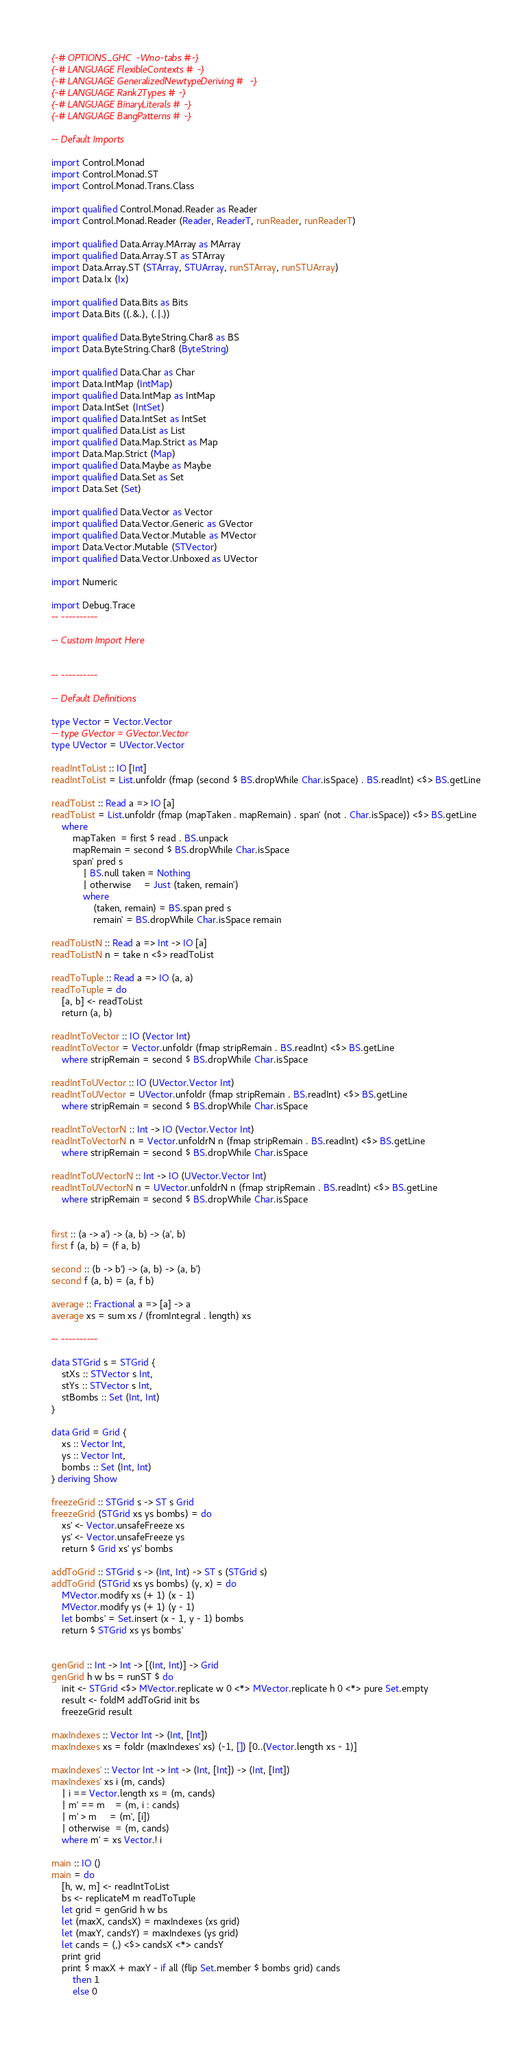<code> <loc_0><loc_0><loc_500><loc_500><_Haskell_>{-# OPTIONS_GHC -Wno-tabs #-}
{-# LANGUAGE FlexibleContexts #-}
{-# LANGUAGE GeneralizedNewtypeDeriving #-}
{-# LANGUAGE Rank2Types #-}
{-# LANGUAGE BinaryLiterals #-}
{-# LANGUAGE BangPatterns #-}

-- Default Imports

import Control.Monad
import Control.Monad.ST
import Control.Monad.Trans.Class

import qualified Control.Monad.Reader as Reader
import Control.Monad.Reader (Reader, ReaderT, runReader, runReaderT)

import qualified Data.Array.MArray as MArray
import qualified Data.Array.ST as STArray
import Data.Array.ST (STArray, STUArray, runSTArray, runSTUArray)
import Data.Ix (Ix)

import qualified Data.Bits as Bits
import Data.Bits ((.&.), (.|.))

import qualified Data.ByteString.Char8 as BS
import Data.ByteString.Char8 (ByteString)

import qualified Data.Char as Char
import Data.IntMap (IntMap)
import qualified Data.IntMap as IntMap
import Data.IntSet (IntSet)
import qualified Data.IntSet as IntSet
import qualified Data.List as List
import qualified Data.Map.Strict as Map
import Data.Map.Strict (Map)
import qualified Data.Maybe as Maybe
import qualified Data.Set as Set
import Data.Set (Set)

import qualified Data.Vector as Vector
import qualified Data.Vector.Generic as GVector
import qualified Data.Vector.Mutable as MVector
import Data.Vector.Mutable (STVector)
import qualified Data.Vector.Unboxed as UVector

import Numeric

import Debug.Trace
-- ----------

-- Custom Import Here


-- ----------

-- Default Definitions

type Vector = Vector.Vector
-- type GVector = GVector.Vector
type UVector = UVector.Vector

readIntToList :: IO [Int]
readIntToList = List.unfoldr (fmap (second $ BS.dropWhile Char.isSpace) . BS.readInt) <$> BS.getLine

readToList :: Read a => IO [a]
readToList = List.unfoldr (fmap (mapTaken . mapRemain) . span' (not . Char.isSpace)) <$> BS.getLine
	where
		mapTaken  = first $ read . BS.unpack
		mapRemain = second $ BS.dropWhile Char.isSpace
		span' pred s
			| BS.null taken = Nothing
			| otherwise     = Just (taken, remain')
			where
				(taken, remain) = BS.span pred s
				remain' = BS.dropWhile Char.isSpace remain

readToListN :: Read a => Int -> IO [a]
readToListN n = take n <$> readToList

readToTuple :: Read a => IO (a, a)
readToTuple = do
	[a, b] <- readToList
	return (a, b)

readIntToVector :: IO (Vector Int)
readIntToVector = Vector.unfoldr (fmap stripRemain . BS.readInt) <$> BS.getLine
	where stripRemain = second $ BS.dropWhile Char.isSpace

readIntToUVector :: IO (UVector.Vector Int)
readIntToUVector = UVector.unfoldr (fmap stripRemain . BS.readInt) <$> BS.getLine
	where stripRemain = second $ BS.dropWhile Char.isSpace

readIntToVectorN :: Int -> IO (Vector.Vector Int)
readIntToVectorN n = Vector.unfoldrN n (fmap stripRemain . BS.readInt) <$> BS.getLine
	where stripRemain = second $ BS.dropWhile Char.isSpace

readIntToUVectorN :: Int -> IO (UVector.Vector Int)
readIntToUVectorN n = UVector.unfoldrN n (fmap stripRemain . BS.readInt) <$> BS.getLine
	where stripRemain = second $ BS.dropWhile Char.isSpace


first :: (a -> a') -> (a, b) -> (a', b)
first f (a, b) = (f a, b)

second :: (b -> b') -> (a, b) -> (a, b')
second f (a, b) = (a, f b)

average :: Fractional a => [a] -> a
average xs = sum xs / (fromIntegral . length) xs

-- ----------

data STGrid s = STGrid {
	stXs :: STVector s Int,
	stYs :: STVector s Int,
	stBombs :: Set (Int, Int)
}

data Grid = Grid {
	xs :: Vector Int,
	ys :: Vector Int,
	bombs :: Set (Int, Int)
} deriving Show

freezeGrid :: STGrid s -> ST s Grid
freezeGrid (STGrid xs ys bombs) = do
	xs' <- Vector.unsafeFreeze xs
	ys' <- Vector.unsafeFreeze ys
	return $ Grid xs' ys' bombs

addToGrid :: STGrid s -> (Int, Int) -> ST s (STGrid s)
addToGrid (STGrid xs ys bombs) (y, x) = do
	MVector.modify xs (+ 1) (x - 1)
	MVector.modify ys (+ 1) (y - 1)
	let bombs' = Set.insert (x - 1, y - 1) bombs
	return $ STGrid xs ys bombs'


genGrid :: Int -> Int -> [(Int, Int)] -> Grid
genGrid h w bs = runST $ do
	init <- STGrid <$> MVector.replicate w 0 <*> MVector.replicate h 0 <*> pure Set.empty
	result <- foldM addToGrid init bs
	freezeGrid result

maxIndexes :: Vector Int -> (Int, [Int])
maxIndexes xs = foldr (maxIndexes' xs) (-1, []) [0..(Vector.length xs - 1)]

maxIndexes' :: Vector Int -> Int -> (Int, [Int]) -> (Int, [Int])
maxIndexes' xs i (m, cands)
	| i == Vector.length xs = (m, cands)
	| m' == m    = (m, i : cands)
	| m' > m     = (m', [i])
	| otherwise  = (m, cands)
	where m' = xs Vector.! i

main :: IO ()
main = do
	[h, w, m] <- readIntToList
	bs <- replicateM m readToTuple
	let grid = genGrid h w bs
	let (maxX, candsX) = maxIndexes (xs grid)
	let (maxY, candsY) = maxIndexes (ys grid)
	let cands = (,) <$> candsX <*> candsY
	print grid
	print $ maxX + maxY - if all (flip Set.member $ bombs grid) cands
		then 1
		else 0
</code> 